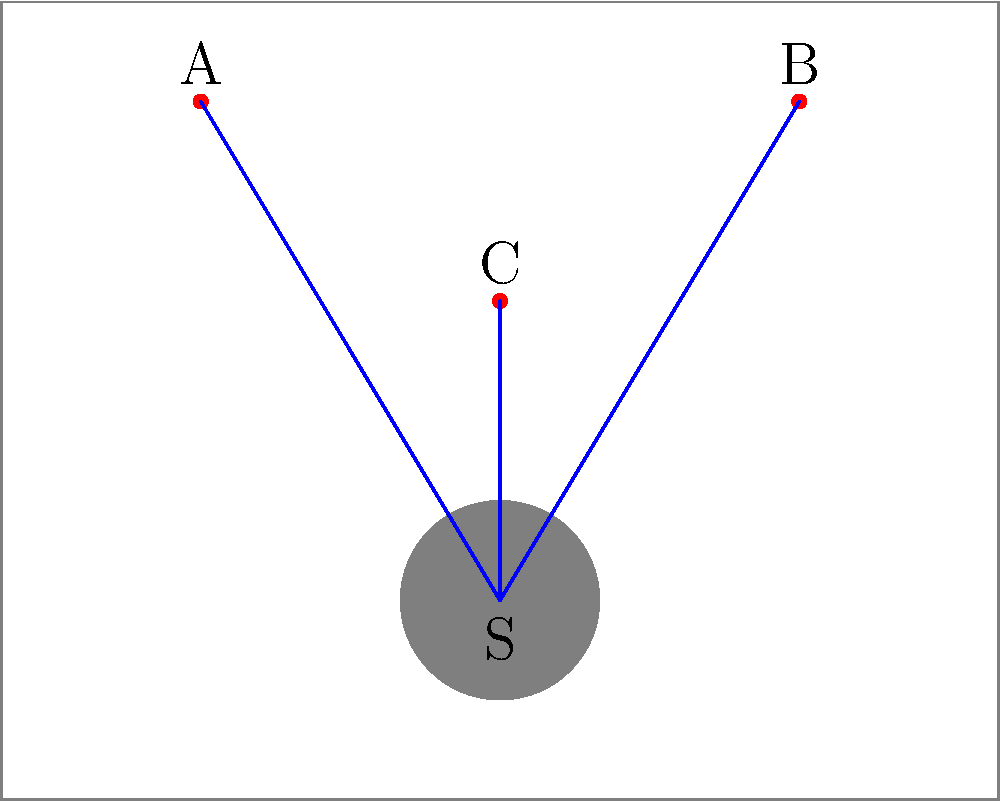In this studio lighting setup, three light sources (A, B, and C) are directed at a subject (S). Considering the light paths as edges and the light sources and subject as vertices, what is the genus of the resulting topological surface? To determine the genus of the topological surface formed by the light paths, we need to follow these steps:

1. Identify the number of vertices (V):
   There are 4 vertices (A, B, C, and S)

2. Identify the number of edges (E):
   There are 3 edges (A-S, B-S, C-S)

3. Identify the number of faces (F):
   There are 2 faces (the triangles ACS and BCS)

4. Apply Euler's formula for planar graphs: V - E + F = 2
   4 - 3 + 2 = 3

5. The Euler characteristic (χ) for this graph is 3

6. Use the formula for genus (g) of a surface:
   χ = 2 - 2g

7. Solve for g:
   3 = 2 - 2g
   2g = -1
   g = -1/2

The genus is not a positive integer, which means this graph cannot be embedded on a simple closed surface without intersections. In topological terms, this indicates that the graph is non-planar.
Answer: Non-planar (g = -1/2) 